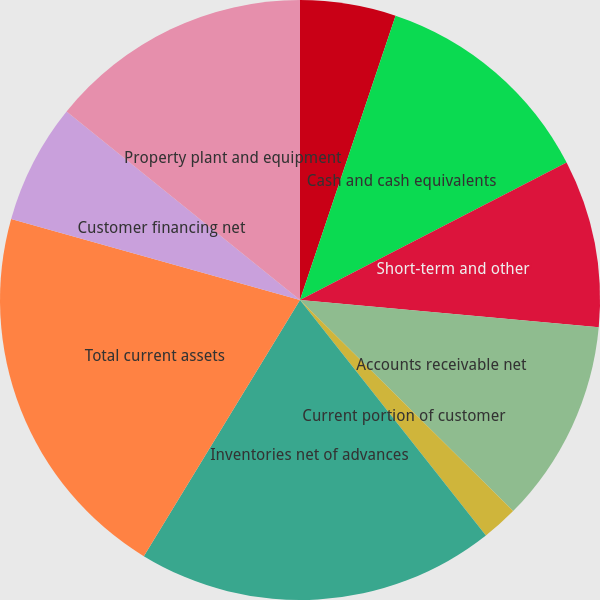Convert chart to OTSL. <chart><loc_0><loc_0><loc_500><loc_500><pie_chart><fcel>(Dollars in millions except<fcel>Cash and cash equivalents<fcel>Short-term and other<fcel>Accounts receivable net<fcel>Current portion of customer<fcel>Deferred income taxes<fcel>Inventories net of advances<fcel>Total current assets<fcel>Customer financing net<fcel>Property plant and equipment<nl><fcel>5.16%<fcel>12.26%<fcel>9.03%<fcel>10.97%<fcel>1.94%<fcel>0.0%<fcel>19.35%<fcel>20.64%<fcel>6.45%<fcel>14.19%<nl></chart> 